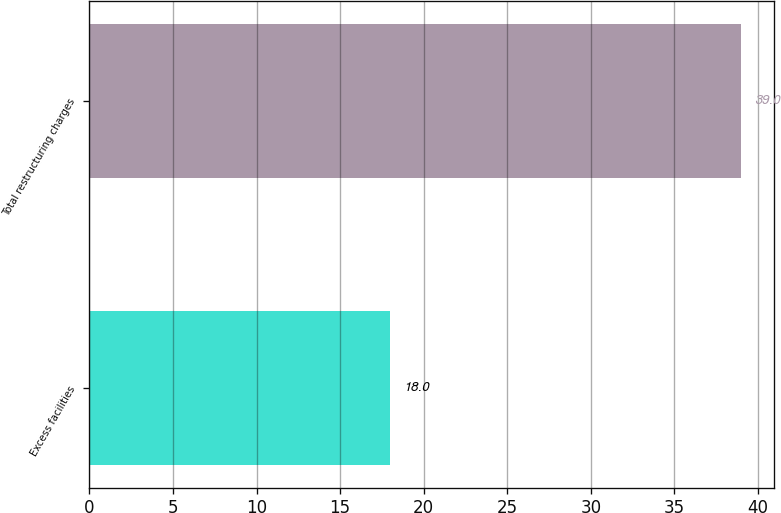<chart> <loc_0><loc_0><loc_500><loc_500><bar_chart><fcel>Excess facilities<fcel>Total restructuring charges<nl><fcel>18<fcel>39<nl></chart> 